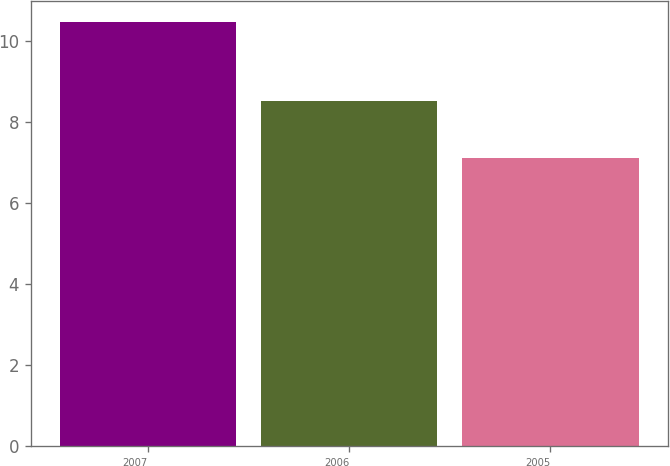Convert chart to OTSL. <chart><loc_0><loc_0><loc_500><loc_500><bar_chart><fcel>2007<fcel>2006<fcel>2005<nl><fcel>10.46<fcel>8.51<fcel>7.11<nl></chart> 